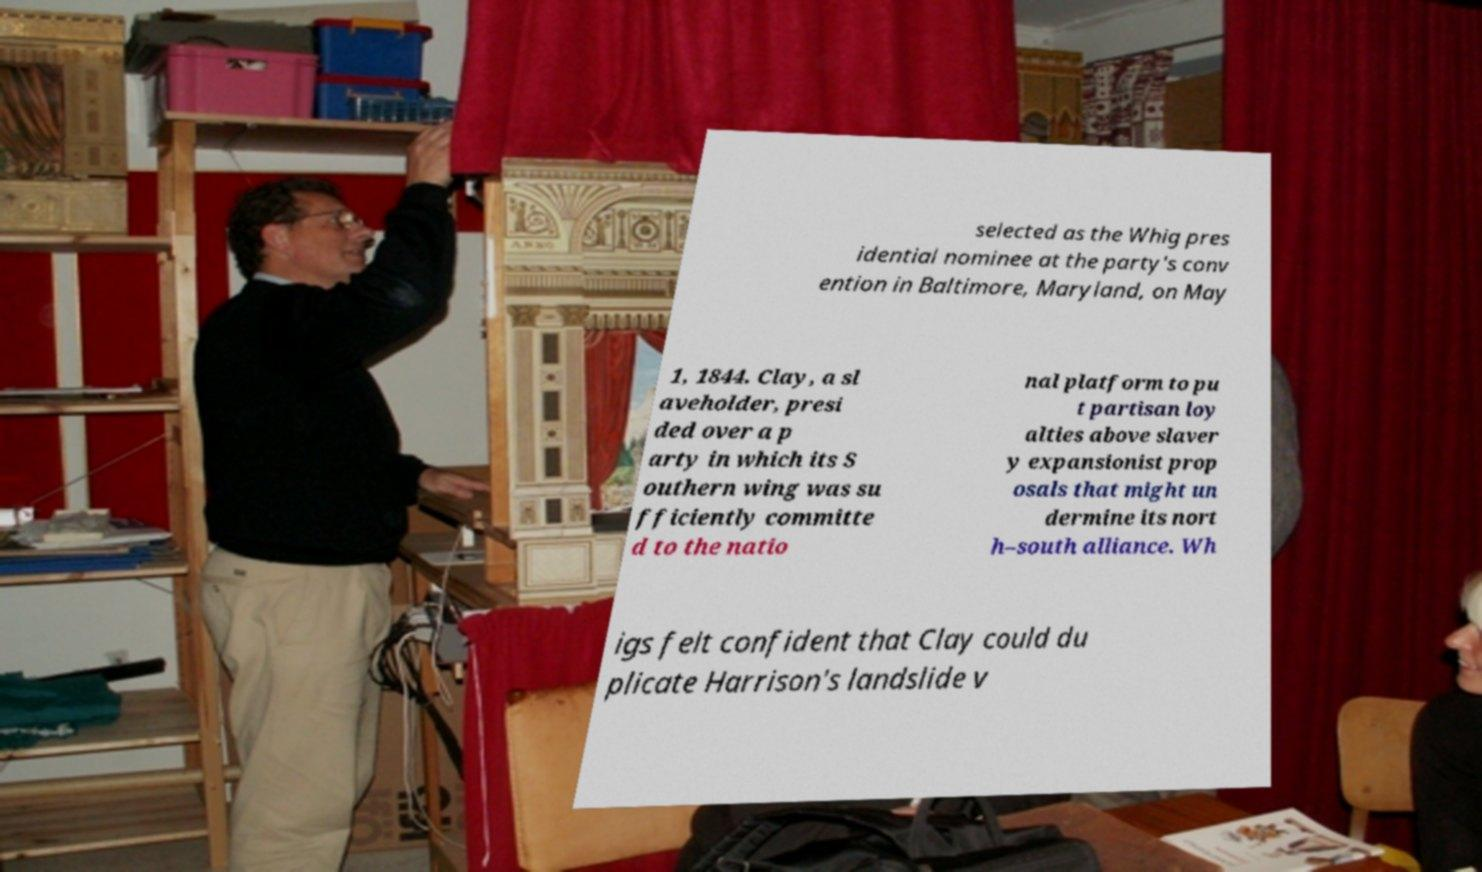Can you accurately transcribe the text from the provided image for me? selected as the Whig pres idential nominee at the party's conv ention in Baltimore, Maryland, on May 1, 1844. Clay, a sl aveholder, presi ded over a p arty in which its S outhern wing was su fficiently committe d to the natio nal platform to pu t partisan loy alties above slaver y expansionist prop osals that might un dermine its nort h–south alliance. Wh igs felt confident that Clay could du plicate Harrison's landslide v 